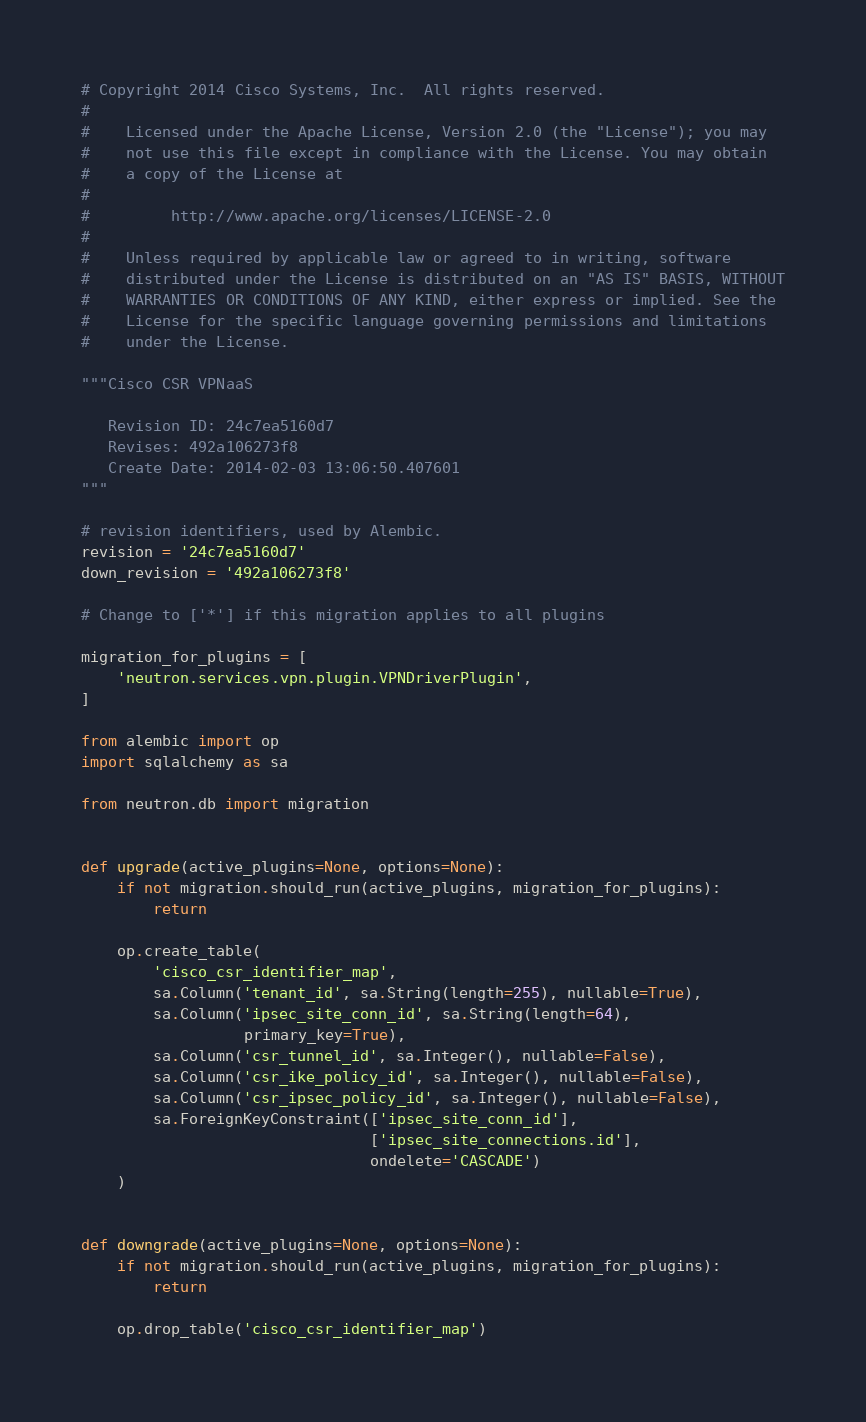<code> <loc_0><loc_0><loc_500><loc_500><_Python_># Copyright 2014 Cisco Systems, Inc.  All rights reserved.
#
#    Licensed under the Apache License, Version 2.0 (the "License"); you may
#    not use this file except in compliance with the License. You may obtain
#    a copy of the License at
#
#         http://www.apache.org/licenses/LICENSE-2.0
#
#    Unless required by applicable law or agreed to in writing, software
#    distributed under the License is distributed on an "AS IS" BASIS, WITHOUT
#    WARRANTIES OR CONDITIONS OF ANY KIND, either express or implied. See the
#    License for the specific language governing permissions and limitations
#    under the License.

"""Cisco CSR VPNaaS

   Revision ID: 24c7ea5160d7
   Revises: 492a106273f8
   Create Date: 2014-02-03 13:06:50.407601
"""

# revision identifiers, used by Alembic.
revision = '24c7ea5160d7'
down_revision = '492a106273f8'

# Change to ['*'] if this migration applies to all plugins

migration_for_plugins = [
    'neutron.services.vpn.plugin.VPNDriverPlugin',
]

from alembic import op
import sqlalchemy as sa

from neutron.db import migration


def upgrade(active_plugins=None, options=None):
    if not migration.should_run(active_plugins, migration_for_plugins):
        return

    op.create_table(
        'cisco_csr_identifier_map',
        sa.Column('tenant_id', sa.String(length=255), nullable=True),
        sa.Column('ipsec_site_conn_id', sa.String(length=64),
                  primary_key=True),
        sa.Column('csr_tunnel_id', sa.Integer(), nullable=False),
        sa.Column('csr_ike_policy_id', sa.Integer(), nullable=False),
        sa.Column('csr_ipsec_policy_id', sa.Integer(), nullable=False),
        sa.ForeignKeyConstraint(['ipsec_site_conn_id'],
                                ['ipsec_site_connections.id'],
                                ondelete='CASCADE')
    )


def downgrade(active_plugins=None, options=None):
    if not migration.should_run(active_plugins, migration_for_plugins):
        return

    op.drop_table('cisco_csr_identifier_map')
</code> 